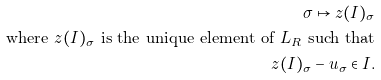Convert formula to latex. <formula><loc_0><loc_0><loc_500><loc_500>\sigma \mapsto z ( I ) _ { \sigma } \\ \text {where } z ( I ) _ { \sigma } \text { is the unique element of $L_{R}$ such that} \\ z ( I ) _ { \sigma } - u _ { \sigma } \in I .</formula> 